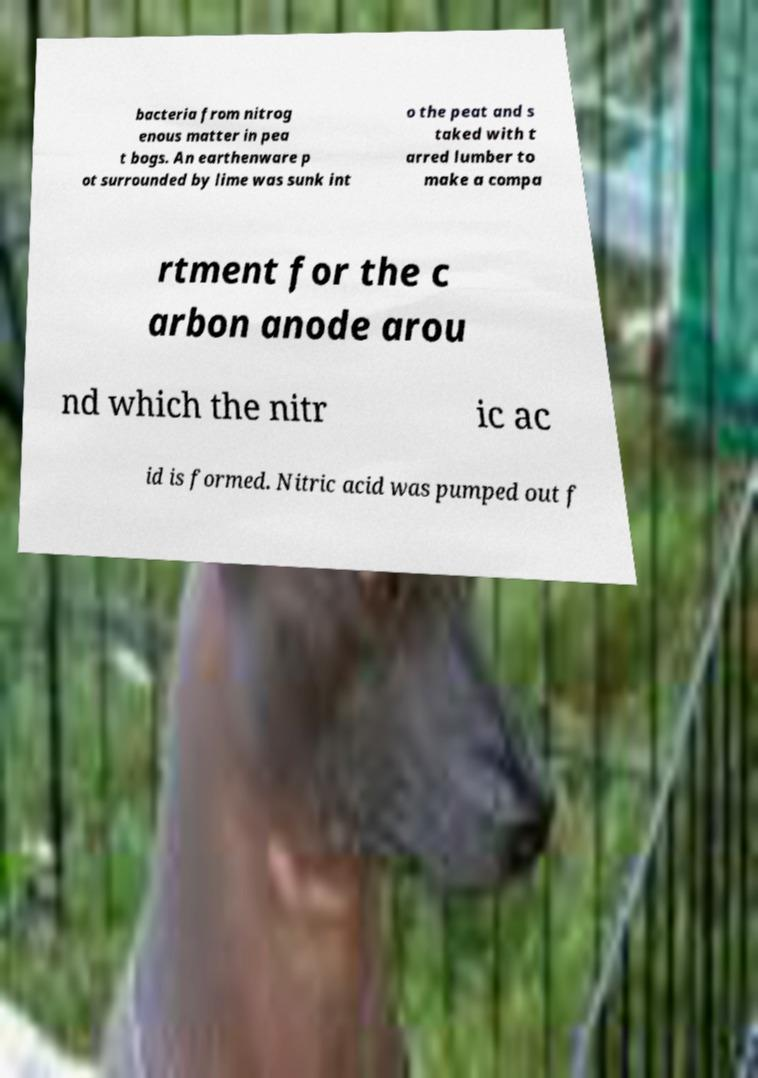Can you read and provide the text displayed in the image?This photo seems to have some interesting text. Can you extract and type it out for me? bacteria from nitrog enous matter in pea t bogs. An earthenware p ot surrounded by lime was sunk int o the peat and s taked with t arred lumber to make a compa rtment for the c arbon anode arou nd which the nitr ic ac id is formed. Nitric acid was pumped out f 